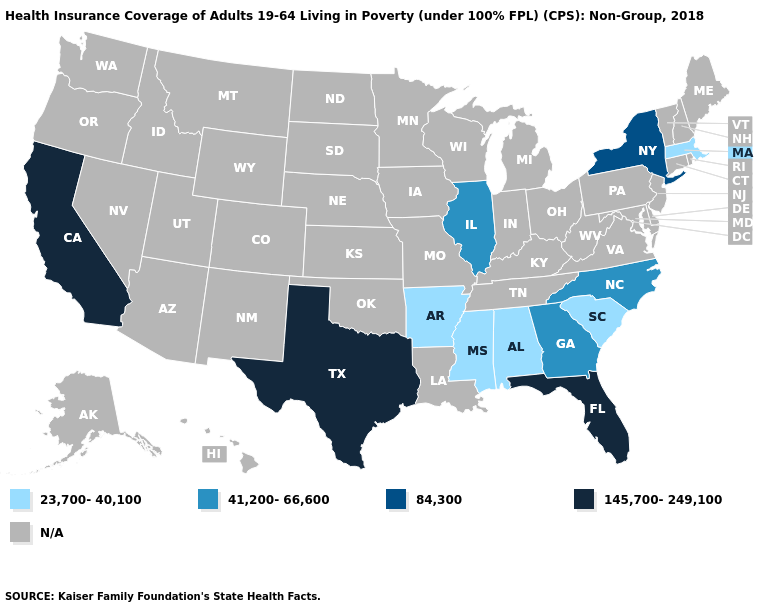What is the lowest value in states that border Mississippi?
Quick response, please. 23,700-40,100. Name the states that have a value in the range 145,700-249,100?
Short answer required. California, Florida, Texas. Name the states that have a value in the range 41,200-66,600?
Quick response, please. Georgia, Illinois, North Carolina. Does Alabama have the highest value in the USA?
Write a very short answer. No. What is the lowest value in the Northeast?
Write a very short answer. 23,700-40,100. Name the states that have a value in the range N/A?
Quick response, please. Alaska, Arizona, Colorado, Connecticut, Delaware, Hawaii, Idaho, Indiana, Iowa, Kansas, Kentucky, Louisiana, Maine, Maryland, Michigan, Minnesota, Missouri, Montana, Nebraska, Nevada, New Hampshire, New Jersey, New Mexico, North Dakota, Ohio, Oklahoma, Oregon, Pennsylvania, Rhode Island, South Dakota, Tennessee, Utah, Vermont, Virginia, Washington, West Virginia, Wisconsin, Wyoming. What is the value of Ohio?
Write a very short answer. N/A. Does Massachusetts have the highest value in the Northeast?
Quick response, please. No. Name the states that have a value in the range 23,700-40,100?
Keep it brief. Alabama, Arkansas, Massachusetts, Mississippi, South Carolina. Among the states that border Massachusetts , which have the highest value?
Write a very short answer. New York. What is the lowest value in the USA?
Answer briefly. 23,700-40,100. Which states have the lowest value in the USA?
Give a very brief answer. Alabama, Arkansas, Massachusetts, Mississippi, South Carolina. Name the states that have a value in the range 41,200-66,600?
Give a very brief answer. Georgia, Illinois, North Carolina. 